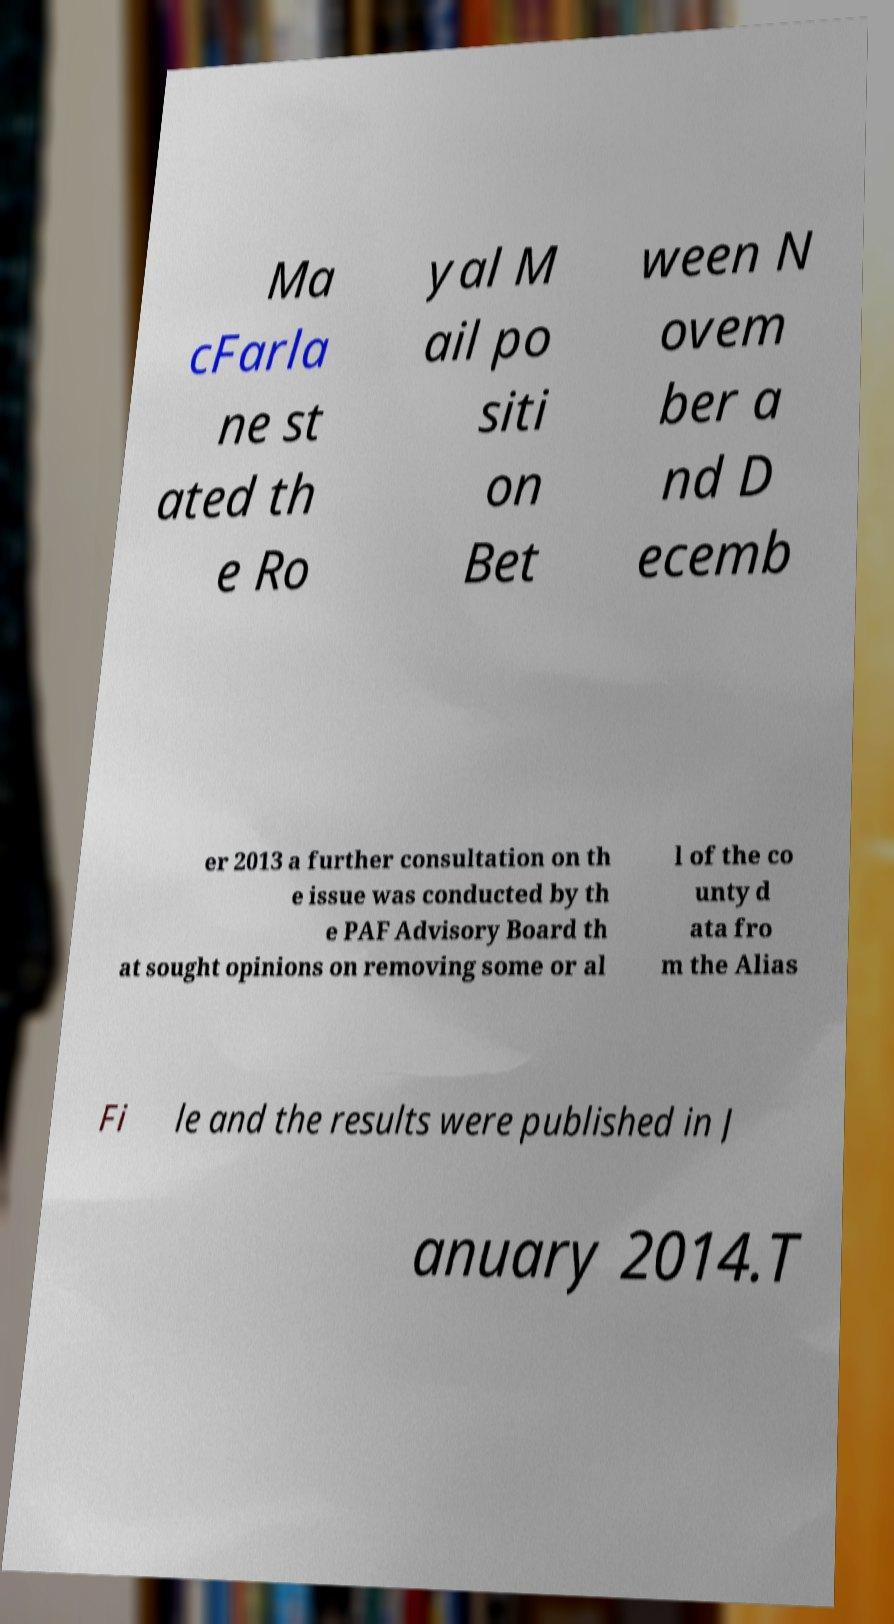For documentation purposes, I need the text within this image transcribed. Could you provide that? Ma cFarla ne st ated th e Ro yal M ail po siti on Bet ween N ovem ber a nd D ecemb er 2013 a further consultation on th e issue was conducted by th e PAF Advisory Board th at sought opinions on removing some or al l of the co unty d ata fro m the Alias Fi le and the results were published in J anuary 2014.T 